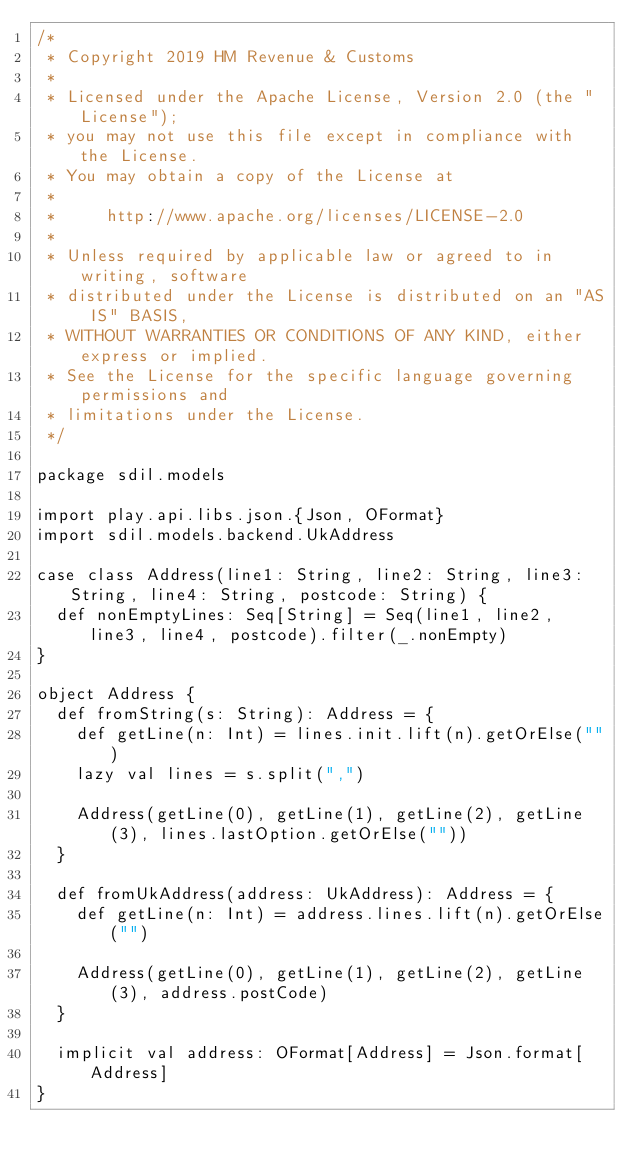Convert code to text. <code><loc_0><loc_0><loc_500><loc_500><_Scala_>/*
 * Copyright 2019 HM Revenue & Customs
 *
 * Licensed under the Apache License, Version 2.0 (the "License");
 * you may not use this file except in compliance with the License.
 * You may obtain a copy of the License at
 *
 *     http://www.apache.org/licenses/LICENSE-2.0
 *
 * Unless required by applicable law or agreed to in writing, software
 * distributed under the License is distributed on an "AS IS" BASIS,
 * WITHOUT WARRANTIES OR CONDITIONS OF ANY KIND, either express or implied.
 * See the License for the specific language governing permissions and
 * limitations under the License.
 */

package sdil.models

import play.api.libs.json.{Json, OFormat}
import sdil.models.backend.UkAddress

case class Address(line1: String, line2: String, line3: String, line4: String, postcode: String) {
  def nonEmptyLines: Seq[String] = Seq(line1, line2, line3, line4, postcode).filter(_.nonEmpty)
}

object Address {
  def fromString(s: String): Address = {
    def getLine(n: Int) = lines.init.lift(n).getOrElse("")
    lazy val lines = s.split(",")

    Address(getLine(0), getLine(1), getLine(2), getLine(3), lines.lastOption.getOrElse(""))
  }

  def fromUkAddress(address: UkAddress): Address = {
    def getLine(n: Int) = address.lines.lift(n).getOrElse("")

    Address(getLine(0), getLine(1), getLine(2), getLine(3), address.postCode)
  }

  implicit val address: OFormat[Address] = Json.format[Address]
}
</code> 